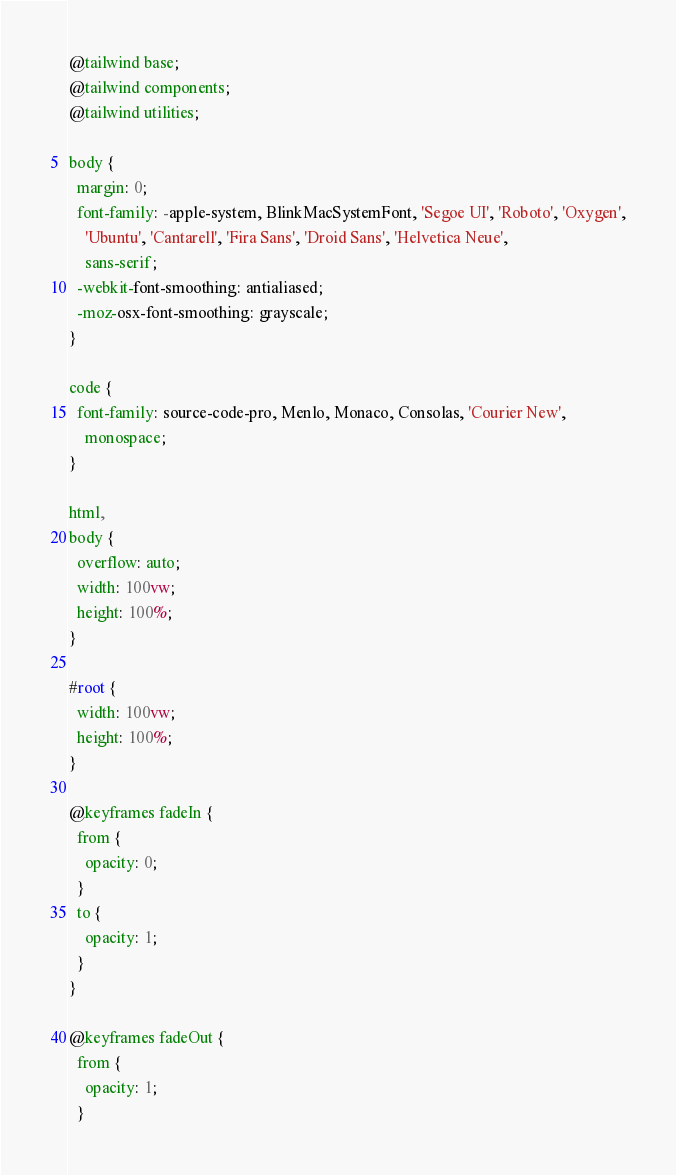Convert code to text. <code><loc_0><loc_0><loc_500><loc_500><_CSS_>@tailwind base;
@tailwind components;
@tailwind utilities;

body {
  margin: 0;
  font-family: -apple-system, BlinkMacSystemFont, 'Segoe UI', 'Roboto', 'Oxygen',
    'Ubuntu', 'Cantarell', 'Fira Sans', 'Droid Sans', 'Helvetica Neue',
    sans-serif;
  -webkit-font-smoothing: antialiased;
  -moz-osx-font-smoothing: grayscale;
}

code {
  font-family: source-code-pro, Menlo, Monaco, Consolas, 'Courier New',
    monospace;
}

html,
body {
  overflow: auto;
  width: 100vw;
  height: 100%;
}

#root {
  width: 100vw;
  height: 100%;
}

@keyframes fadeIn {
  from {
    opacity: 0;
  }
  to {
    opacity: 1;
  }
}

@keyframes fadeOut {
  from {
    opacity: 1;
  }</code> 